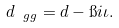<formula> <loc_0><loc_0><loc_500><loc_500>d _ { \ g g } = d - \i i \iota .</formula> 